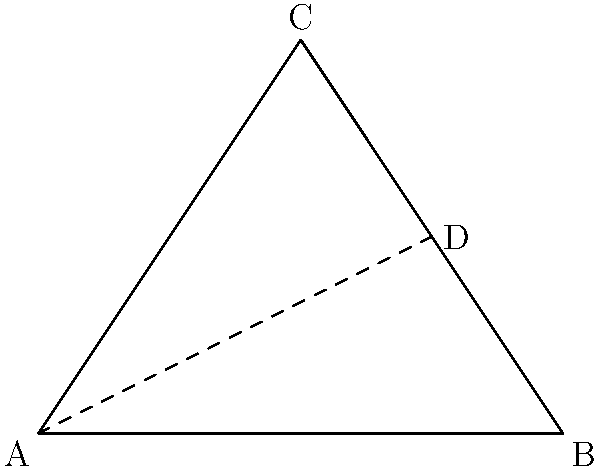In a traditional British fishing net design, the shape of the net opening is often represented by a triangle. Consider the triangular net opening ABC, where AB is the base of the net along the water surface, and C represents the deepest point of the net. If AB = 4 meters, BC = 3 meters, and AC = 3 meters, what is the area of the triangular region ACD, where D is the midpoint of BC? Let's approach this step-by-step:

1) First, we need to find the height of the triangle ABC. We can do this using the Pythagorean theorem.

2) Let h be the height of the triangle. We know that:
   $$AC^2 = (\frac{1}{2}AB)^2 + h^2$$

3) Substituting the known values:
   $$3^2 = 2^2 + h^2$$
   $$9 = 4 + h^2$$
   $$h^2 = 5$$
   $$h = \sqrt{5}$$

4) Now, we know that D is the midpoint of BC. This means that AD is a median of the triangle.

5) A key property of medians is that they divide the opposite side in a 2:1 ratio. This means that the area of ACD is 1/3 of the area of ABC.

6) The area of ABC can be calculated as:
   $$Area_{ABC} = \frac{1}{2} * base * height = \frac{1}{2} * 4 * \sqrt{5}$$

7) Therefore, the area of ACD is:
   $$Area_{ACD} = \frac{1}{3} * Area_{ABC} = \frac{1}{3} * \frac{1}{2} * 4 * \sqrt{5} = \frac{2\sqrt{5}}{3}$$
Answer: $\frac{2\sqrt{5}}{3}$ square meters 